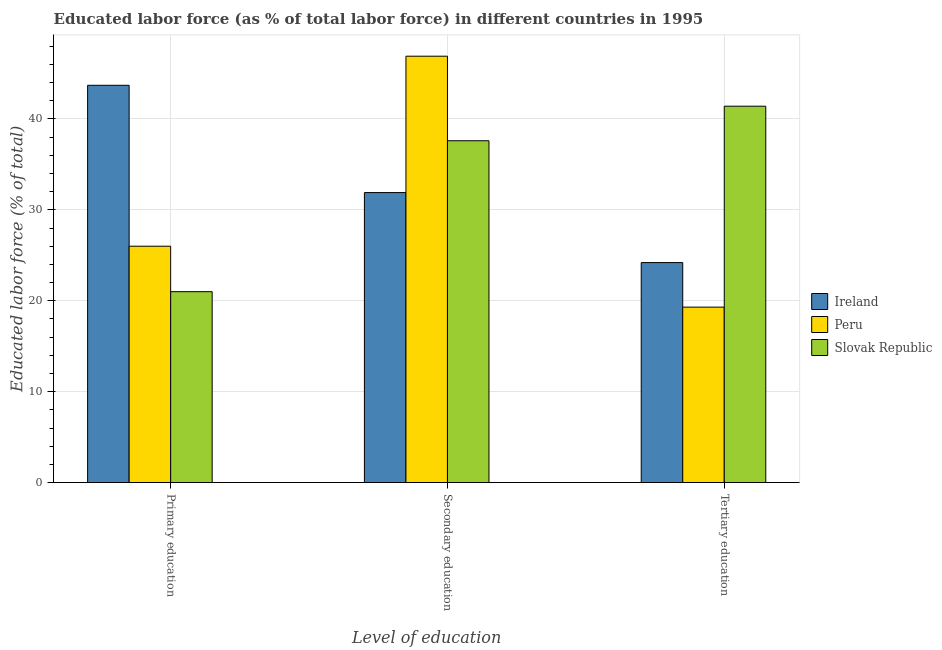Are the number of bars per tick equal to the number of legend labels?
Provide a succinct answer. Yes. How many bars are there on the 1st tick from the left?
Ensure brevity in your answer.  3. How many bars are there on the 1st tick from the right?
Your answer should be very brief. 3. What is the label of the 2nd group of bars from the left?
Provide a short and direct response. Secondary education. What is the percentage of labor force who received primary education in Ireland?
Your answer should be compact. 43.7. Across all countries, what is the maximum percentage of labor force who received primary education?
Provide a short and direct response. 43.7. Across all countries, what is the minimum percentage of labor force who received tertiary education?
Keep it short and to the point. 19.3. In which country was the percentage of labor force who received primary education minimum?
Your response must be concise. Slovak Republic. What is the total percentage of labor force who received tertiary education in the graph?
Make the answer very short. 84.9. What is the difference between the percentage of labor force who received tertiary education in Ireland and that in Slovak Republic?
Offer a terse response. -17.2. What is the difference between the percentage of labor force who received primary education in Ireland and the percentage of labor force who received secondary education in Peru?
Your answer should be compact. -3.2. What is the average percentage of labor force who received tertiary education per country?
Give a very brief answer. 28.3. What is the difference between the percentage of labor force who received secondary education and percentage of labor force who received primary education in Slovak Republic?
Keep it short and to the point. 16.6. What is the ratio of the percentage of labor force who received secondary education in Slovak Republic to that in Ireland?
Your response must be concise. 1.18. Is the percentage of labor force who received primary education in Ireland less than that in Slovak Republic?
Provide a succinct answer. No. Is the difference between the percentage of labor force who received primary education in Peru and Slovak Republic greater than the difference between the percentage of labor force who received tertiary education in Peru and Slovak Republic?
Your answer should be very brief. Yes. What is the difference between the highest and the second highest percentage of labor force who received secondary education?
Offer a terse response. 9.3. What is the difference between the highest and the lowest percentage of labor force who received secondary education?
Make the answer very short. 15. Is the sum of the percentage of labor force who received secondary education in Ireland and Slovak Republic greater than the maximum percentage of labor force who received primary education across all countries?
Provide a short and direct response. Yes. What does the 3rd bar from the left in Tertiary education represents?
Your answer should be compact. Slovak Republic. What does the 3rd bar from the right in Secondary education represents?
Keep it short and to the point. Ireland. How many bars are there?
Your answer should be compact. 9. Are all the bars in the graph horizontal?
Provide a short and direct response. No. What is the difference between two consecutive major ticks on the Y-axis?
Provide a short and direct response. 10. Are the values on the major ticks of Y-axis written in scientific E-notation?
Keep it short and to the point. No. Does the graph contain any zero values?
Give a very brief answer. No. Does the graph contain grids?
Give a very brief answer. Yes. Where does the legend appear in the graph?
Your answer should be very brief. Center right. How are the legend labels stacked?
Make the answer very short. Vertical. What is the title of the graph?
Offer a very short reply. Educated labor force (as % of total labor force) in different countries in 1995. Does "Latin America(developing only)" appear as one of the legend labels in the graph?
Offer a very short reply. No. What is the label or title of the X-axis?
Offer a very short reply. Level of education. What is the label or title of the Y-axis?
Your answer should be compact. Educated labor force (% of total). What is the Educated labor force (% of total) in Ireland in Primary education?
Make the answer very short. 43.7. What is the Educated labor force (% of total) of Ireland in Secondary education?
Provide a succinct answer. 31.9. What is the Educated labor force (% of total) of Peru in Secondary education?
Your answer should be very brief. 46.9. What is the Educated labor force (% of total) in Slovak Republic in Secondary education?
Make the answer very short. 37.6. What is the Educated labor force (% of total) of Ireland in Tertiary education?
Provide a succinct answer. 24.2. What is the Educated labor force (% of total) in Peru in Tertiary education?
Ensure brevity in your answer.  19.3. What is the Educated labor force (% of total) of Slovak Republic in Tertiary education?
Your answer should be very brief. 41.4. Across all Level of education, what is the maximum Educated labor force (% of total) in Ireland?
Your answer should be compact. 43.7. Across all Level of education, what is the maximum Educated labor force (% of total) in Peru?
Provide a short and direct response. 46.9. Across all Level of education, what is the maximum Educated labor force (% of total) in Slovak Republic?
Your answer should be very brief. 41.4. Across all Level of education, what is the minimum Educated labor force (% of total) of Ireland?
Ensure brevity in your answer.  24.2. Across all Level of education, what is the minimum Educated labor force (% of total) in Peru?
Your answer should be very brief. 19.3. What is the total Educated labor force (% of total) of Ireland in the graph?
Your answer should be very brief. 99.8. What is the total Educated labor force (% of total) of Peru in the graph?
Provide a succinct answer. 92.2. What is the total Educated labor force (% of total) of Slovak Republic in the graph?
Offer a terse response. 100. What is the difference between the Educated labor force (% of total) in Peru in Primary education and that in Secondary education?
Give a very brief answer. -20.9. What is the difference between the Educated labor force (% of total) in Slovak Republic in Primary education and that in Secondary education?
Your answer should be very brief. -16.6. What is the difference between the Educated labor force (% of total) in Slovak Republic in Primary education and that in Tertiary education?
Your answer should be very brief. -20.4. What is the difference between the Educated labor force (% of total) in Peru in Secondary education and that in Tertiary education?
Keep it short and to the point. 27.6. What is the difference between the Educated labor force (% of total) of Ireland in Primary education and the Educated labor force (% of total) of Peru in Secondary education?
Provide a succinct answer. -3.2. What is the difference between the Educated labor force (% of total) of Ireland in Primary education and the Educated labor force (% of total) of Slovak Republic in Secondary education?
Keep it short and to the point. 6.1. What is the difference between the Educated labor force (% of total) in Ireland in Primary education and the Educated labor force (% of total) in Peru in Tertiary education?
Provide a short and direct response. 24.4. What is the difference between the Educated labor force (% of total) in Ireland in Primary education and the Educated labor force (% of total) in Slovak Republic in Tertiary education?
Your answer should be very brief. 2.3. What is the difference between the Educated labor force (% of total) in Peru in Primary education and the Educated labor force (% of total) in Slovak Republic in Tertiary education?
Ensure brevity in your answer.  -15.4. What is the difference between the Educated labor force (% of total) in Ireland in Secondary education and the Educated labor force (% of total) in Peru in Tertiary education?
Your response must be concise. 12.6. What is the average Educated labor force (% of total) of Ireland per Level of education?
Offer a terse response. 33.27. What is the average Educated labor force (% of total) of Peru per Level of education?
Give a very brief answer. 30.73. What is the average Educated labor force (% of total) in Slovak Republic per Level of education?
Your response must be concise. 33.33. What is the difference between the Educated labor force (% of total) in Ireland and Educated labor force (% of total) in Peru in Primary education?
Provide a succinct answer. 17.7. What is the difference between the Educated labor force (% of total) in Ireland and Educated labor force (% of total) in Slovak Republic in Primary education?
Your response must be concise. 22.7. What is the difference between the Educated labor force (% of total) in Peru and Educated labor force (% of total) in Slovak Republic in Primary education?
Your answer should be compact. 5. What is the difference between the Educated labor force (% of total) of Ireland and Educated labor force (% of total) of Peru in Secondary education?
Offer a very short reply. -15. What is the difference between the Educated labor force (% of total) of Ireland and Educated labor force (% of total) of Peru in Tertiary education?
Provide a succinct answer. 4.9. What is the difference between the Educated labor force (% of total) in Ireland and Educated labor force (% of total) in Slovak Republic in Tertiary education?
Offer a very short reply. -17.2. What is the difference between the Educated labor force (% of total) of Peru and Educated labor force (% of total) of Slovak Republic in Tertiary education?
Provide a short and direct response. -22.1. What is the ratio of the Educated labor force (% of total) in Ireland in Primary education to that in Secondary education?
Provide a short and direct response. 1.37. What is the ratio of the Educated labor force (% of total) of Peru in Primary education to that in Secondary education?
Provide a succinct answer. 0.55. What is the ratio of the Educated labor force (% of total) in Slovak Republic in Primary education to that in Secondary education?
Your answer should be compact. 0.56. What is the ratio of the Educated labor force (% of total) in Ireland in Primary education to that in Tertiary education?
Offer a very short reply. 1.81. What is the ratio of the Educated labor force (% of total) in Peru in Primary education to that in Tertiary education?
Ensure brevity in your answer.  1.35. What is the ratio of the Educated labor force (% of total) in Slovak Republic in Primary education to that in Tertiary education?
Keep it short and to the point. 0.51. What is the ratio of the Educated labor force (% of total) in Ireland in Secondary education to that in Tertiary education?
Provide a short and direct response. 1.32. What is the ratio of the Educated labor force (% of total) of Peru in Secondary education to that in Tertiary education?
Your response must be concise. 2.43. What is the ratio of the Educated labor force (% of total) of Slovak Republic in Secondary education to that in Tertiary education?
Give a very brief answer. 0.91. What is the difference between the highest and the second highest Educated labor force (% of total) of Peru?
Make the answer very short. 20.9. What is the difference between the highest and the second highest Educated labor force (% of total) in Slovak Republic?
Your answer should be compact. 3.8. What is the difference between the highest and the lowest Educated labor force (% of total) in Peru?
Your answer should be compact. 27.6. What is the difference between the highest and the lowest Educated labor force (% of total) of Slovak Republic?
Your response must be concise. 20.4. 